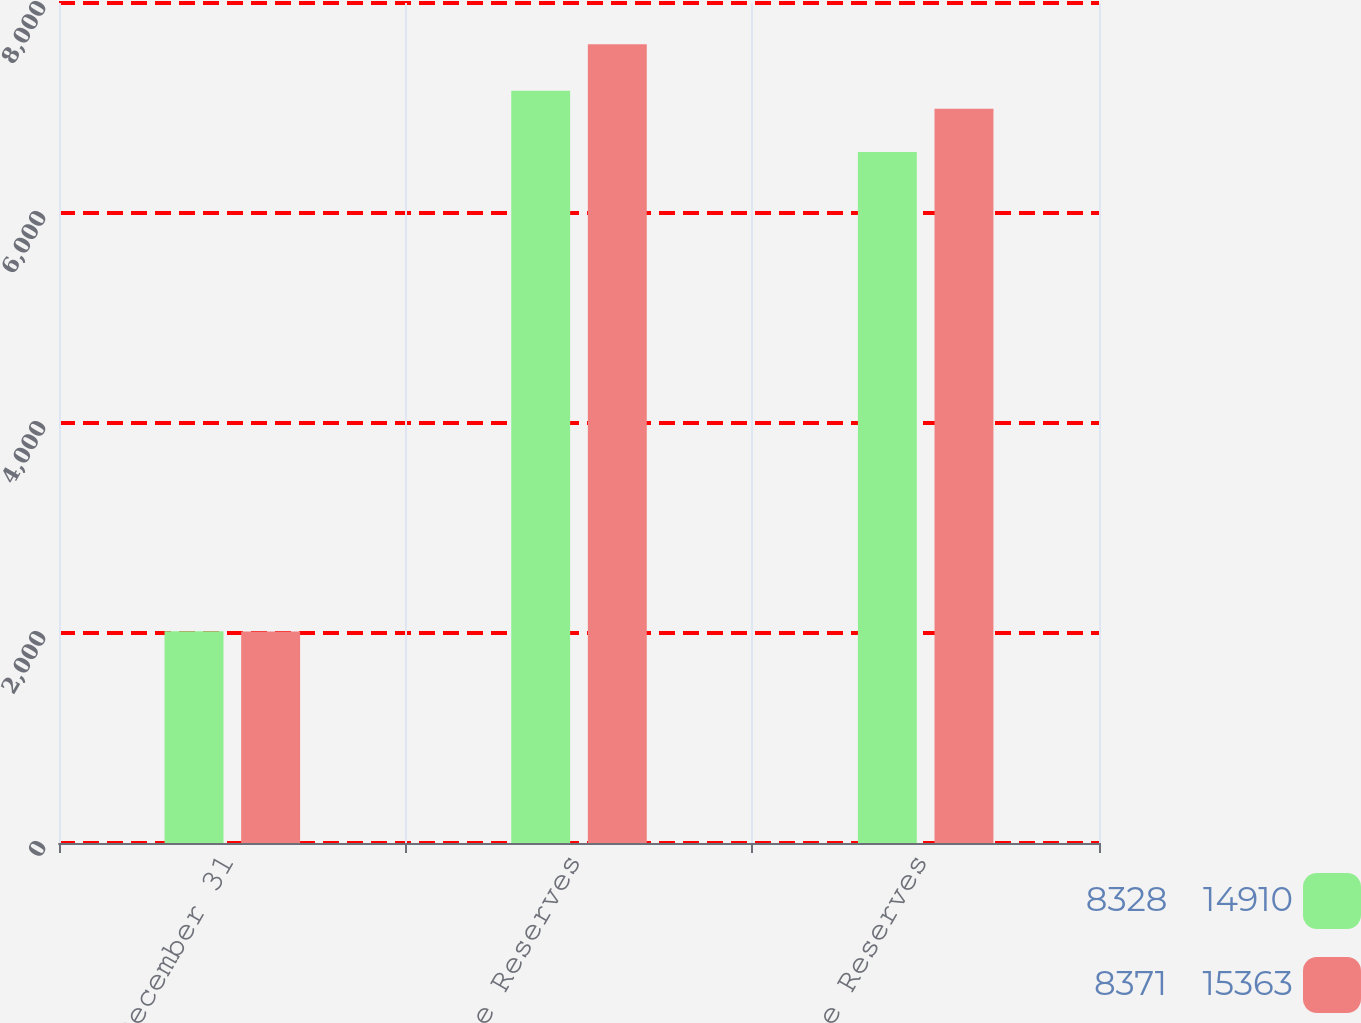Convert chart to OTSL. <chart><loc_0><loc_0><loc_500><loc_500><stacked_bar_chart><ecel><fcel>December 31<fcel>Gross Case Reserves<fcel>Net Case Reserves<nl><fcel>8328    14910<fcel>2016<fcel>7164<fcel>6582<nl><fcel>8371    15363<fcel>2015<fcel>7608<fcel>6992<nl></chart> 